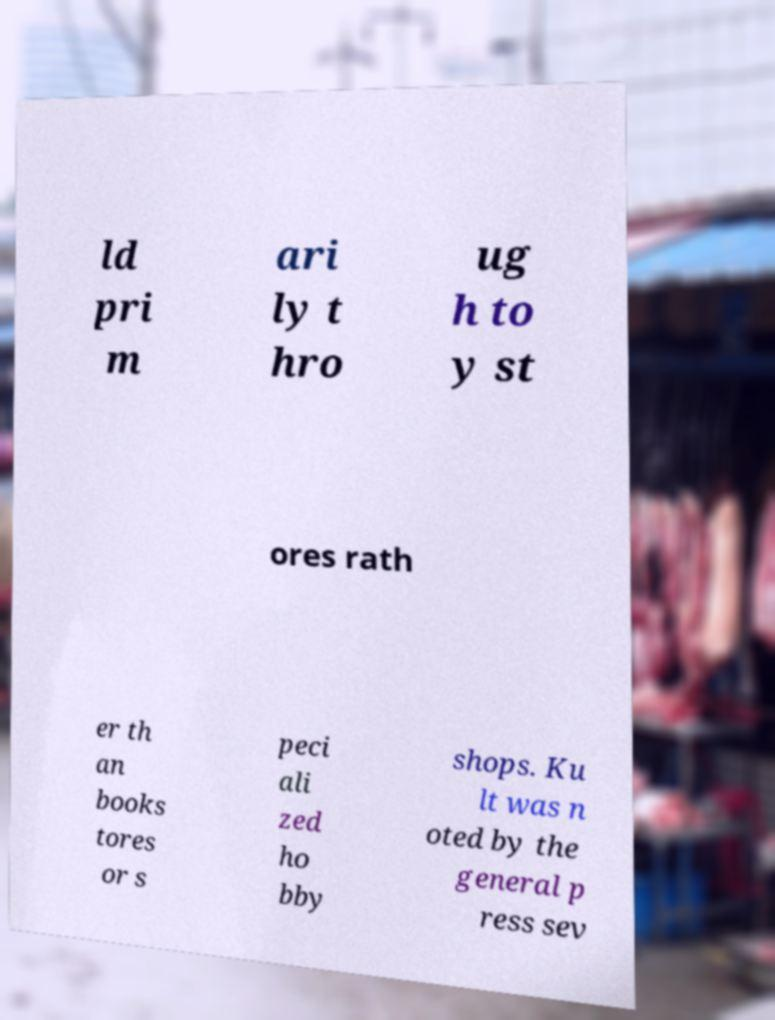Can you read and provide the text displayed in the image?This photo seems to have some interesting text. Can you extract and type it out for me? ld pri m ari ly t hro ug h to y st ores rath er th an books tores or s peci ali zed ho bby shops. Ku lt was n oted by the general p ress sev 